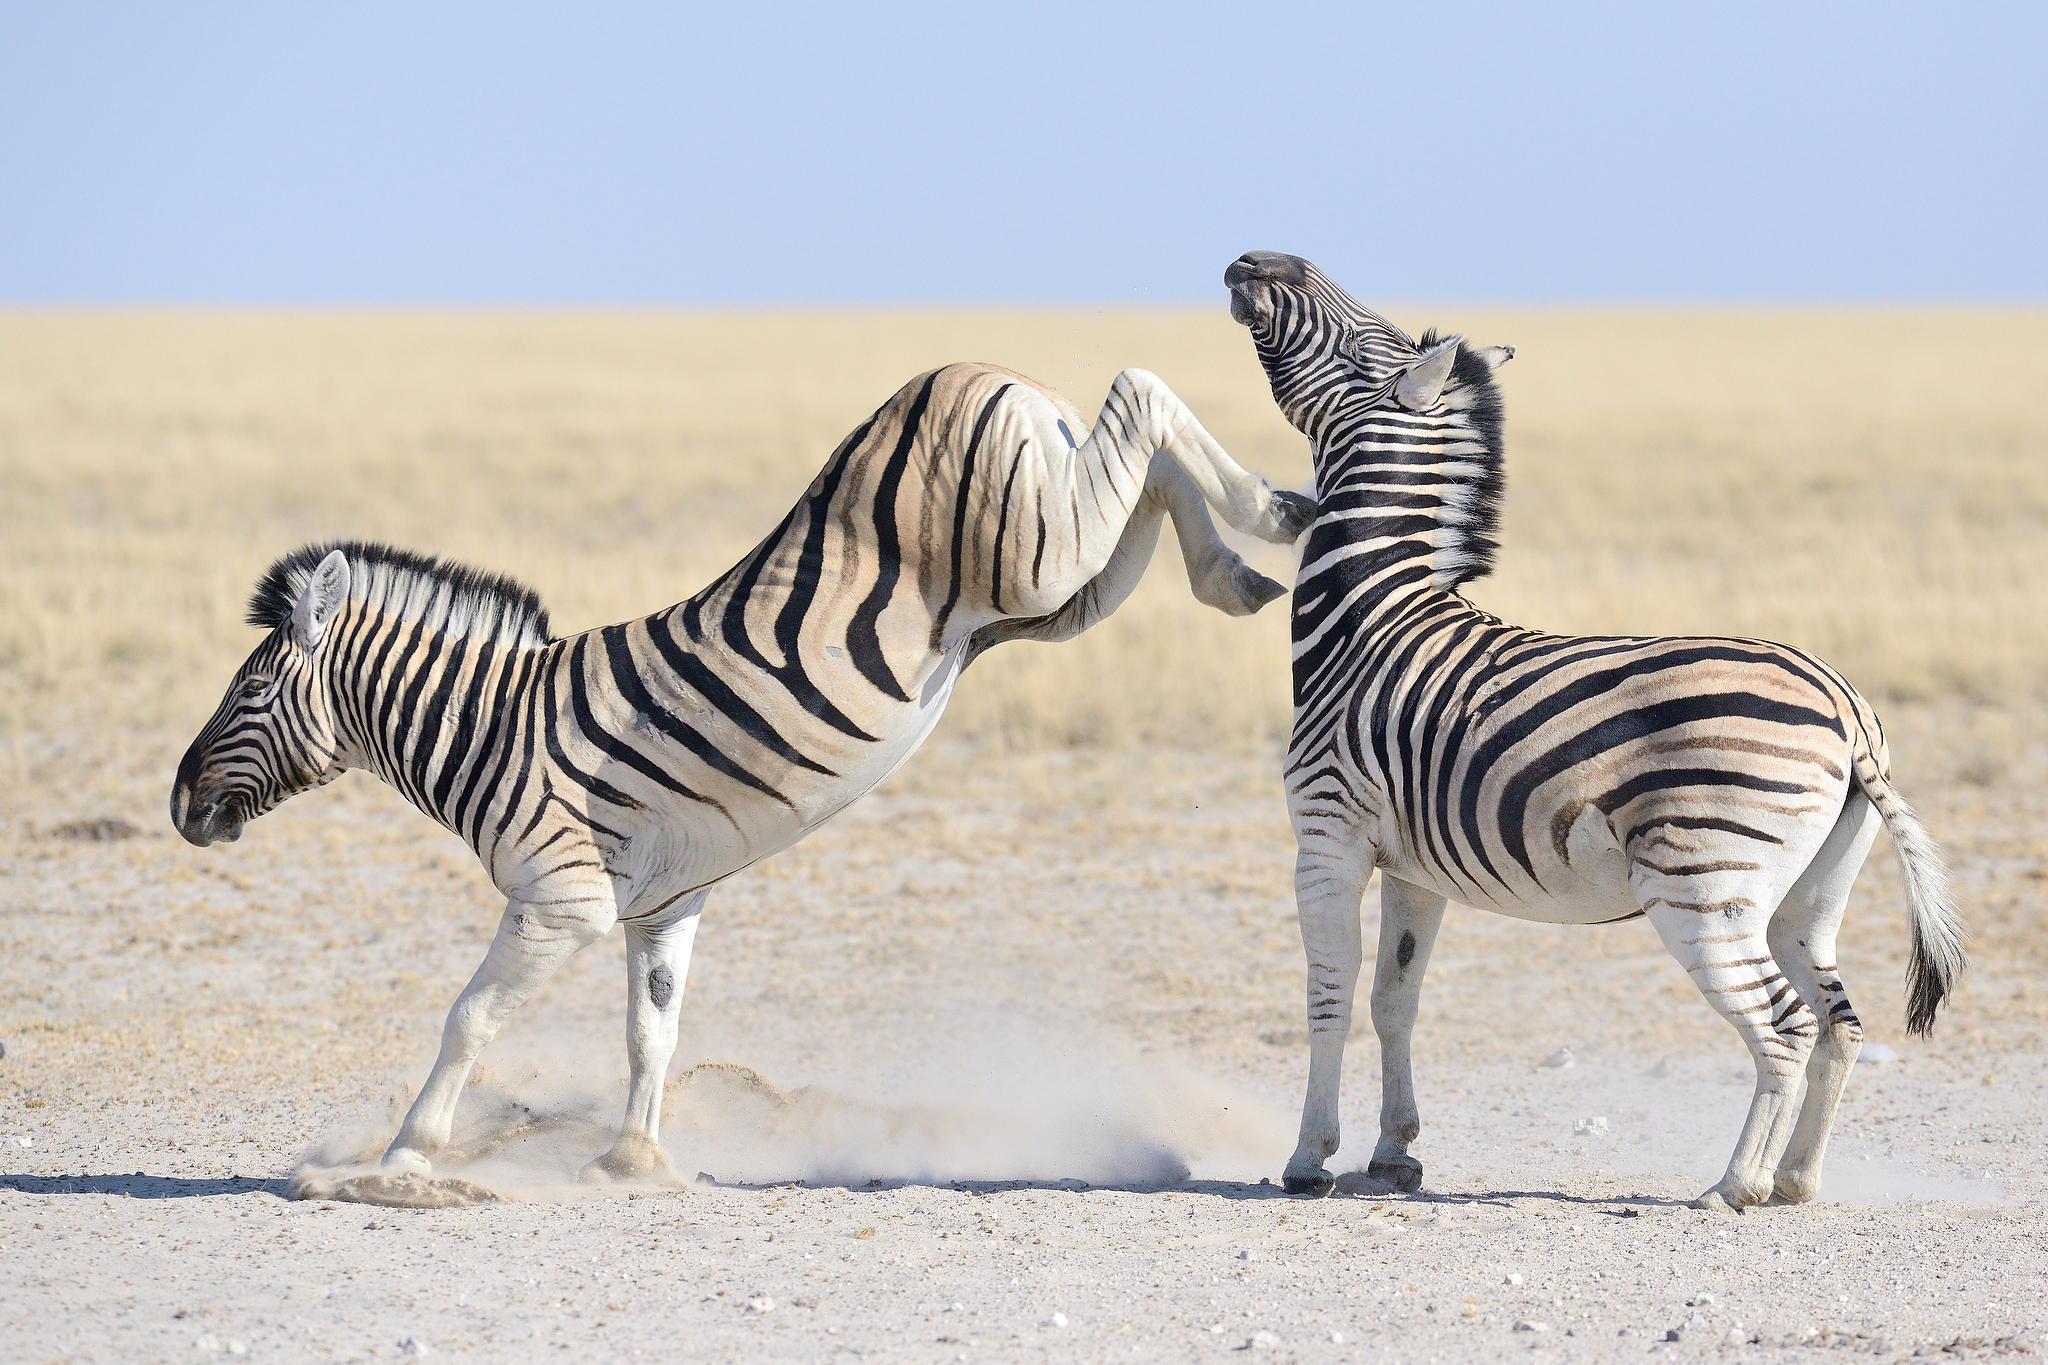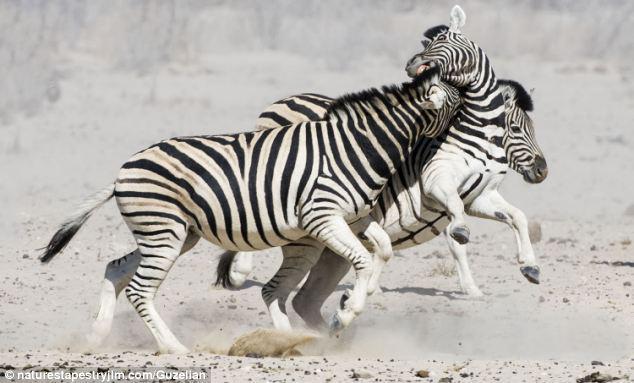The first image is the image on the left, the second image is the image on the right. For the images displayed, is the sentence "One of the images shows a zebra in close contact with a mammal of another species." factually correct? Answer yes or no. No. The first image is the image on the left, the second image is the image on the right. Given the left and right images, does the statement "The photo on the right shows an animal that is not a zebra, and the one on the left shows at least two zebras in a dusty environment." hold true? Answer yes or no. No. 